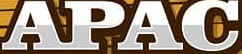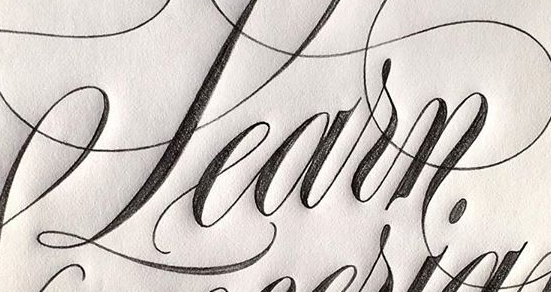What words are shown in these images in order, separated by a semicolon? APAC; Learn 